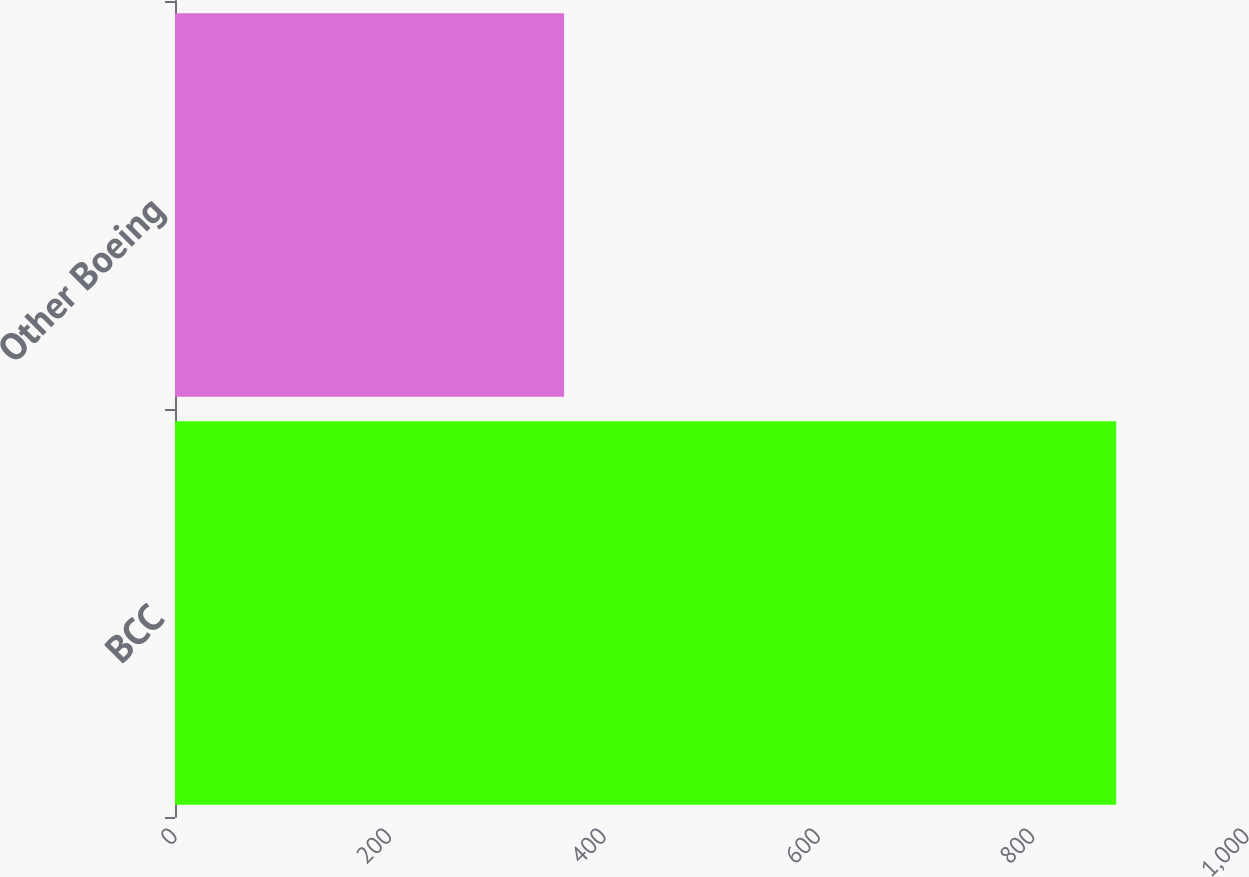Convert chart to OTSL. <chart><loc_0><loc_0><loc_500><loc_500><bar_chart><fcel>BCC<fcel>Other Boeing<nl><fcel>878<fcel>363<nl></chart> 